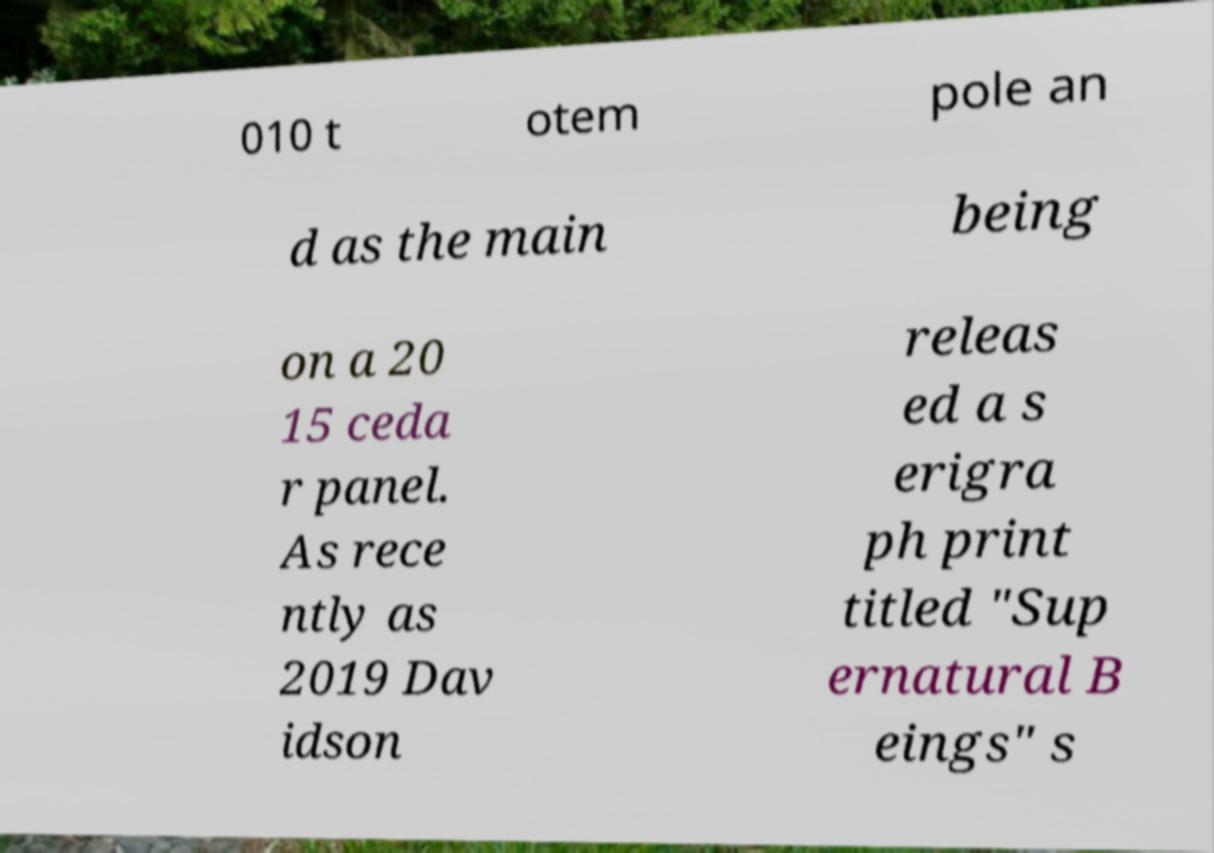Please identify and transcribe the text found in this image. 010 t otem pole an d as the main being on a 20 15 ceda r panel. As rece ntly as 2019 Dav idson releas ed a s erigra ph print titled "Sup ernatural B eings" s 